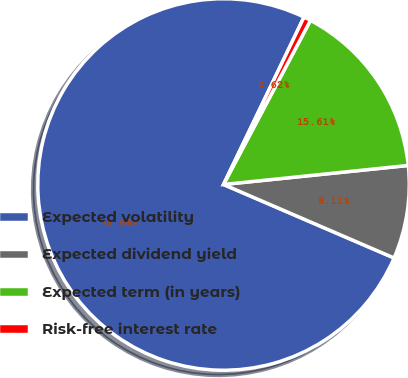Convert chart. <chart><loc_0><loc_0><loc_500><loc_500><pie_chart><fcel>Expected volatility<fcel>Expected dividend yield<fcel>Expected term (in years)<fcel>Risk-free interest rate<nl><fcel>75.66%<fcel>8.11%<fcel>15.61%<fcel>0.62%<nl></chart> 